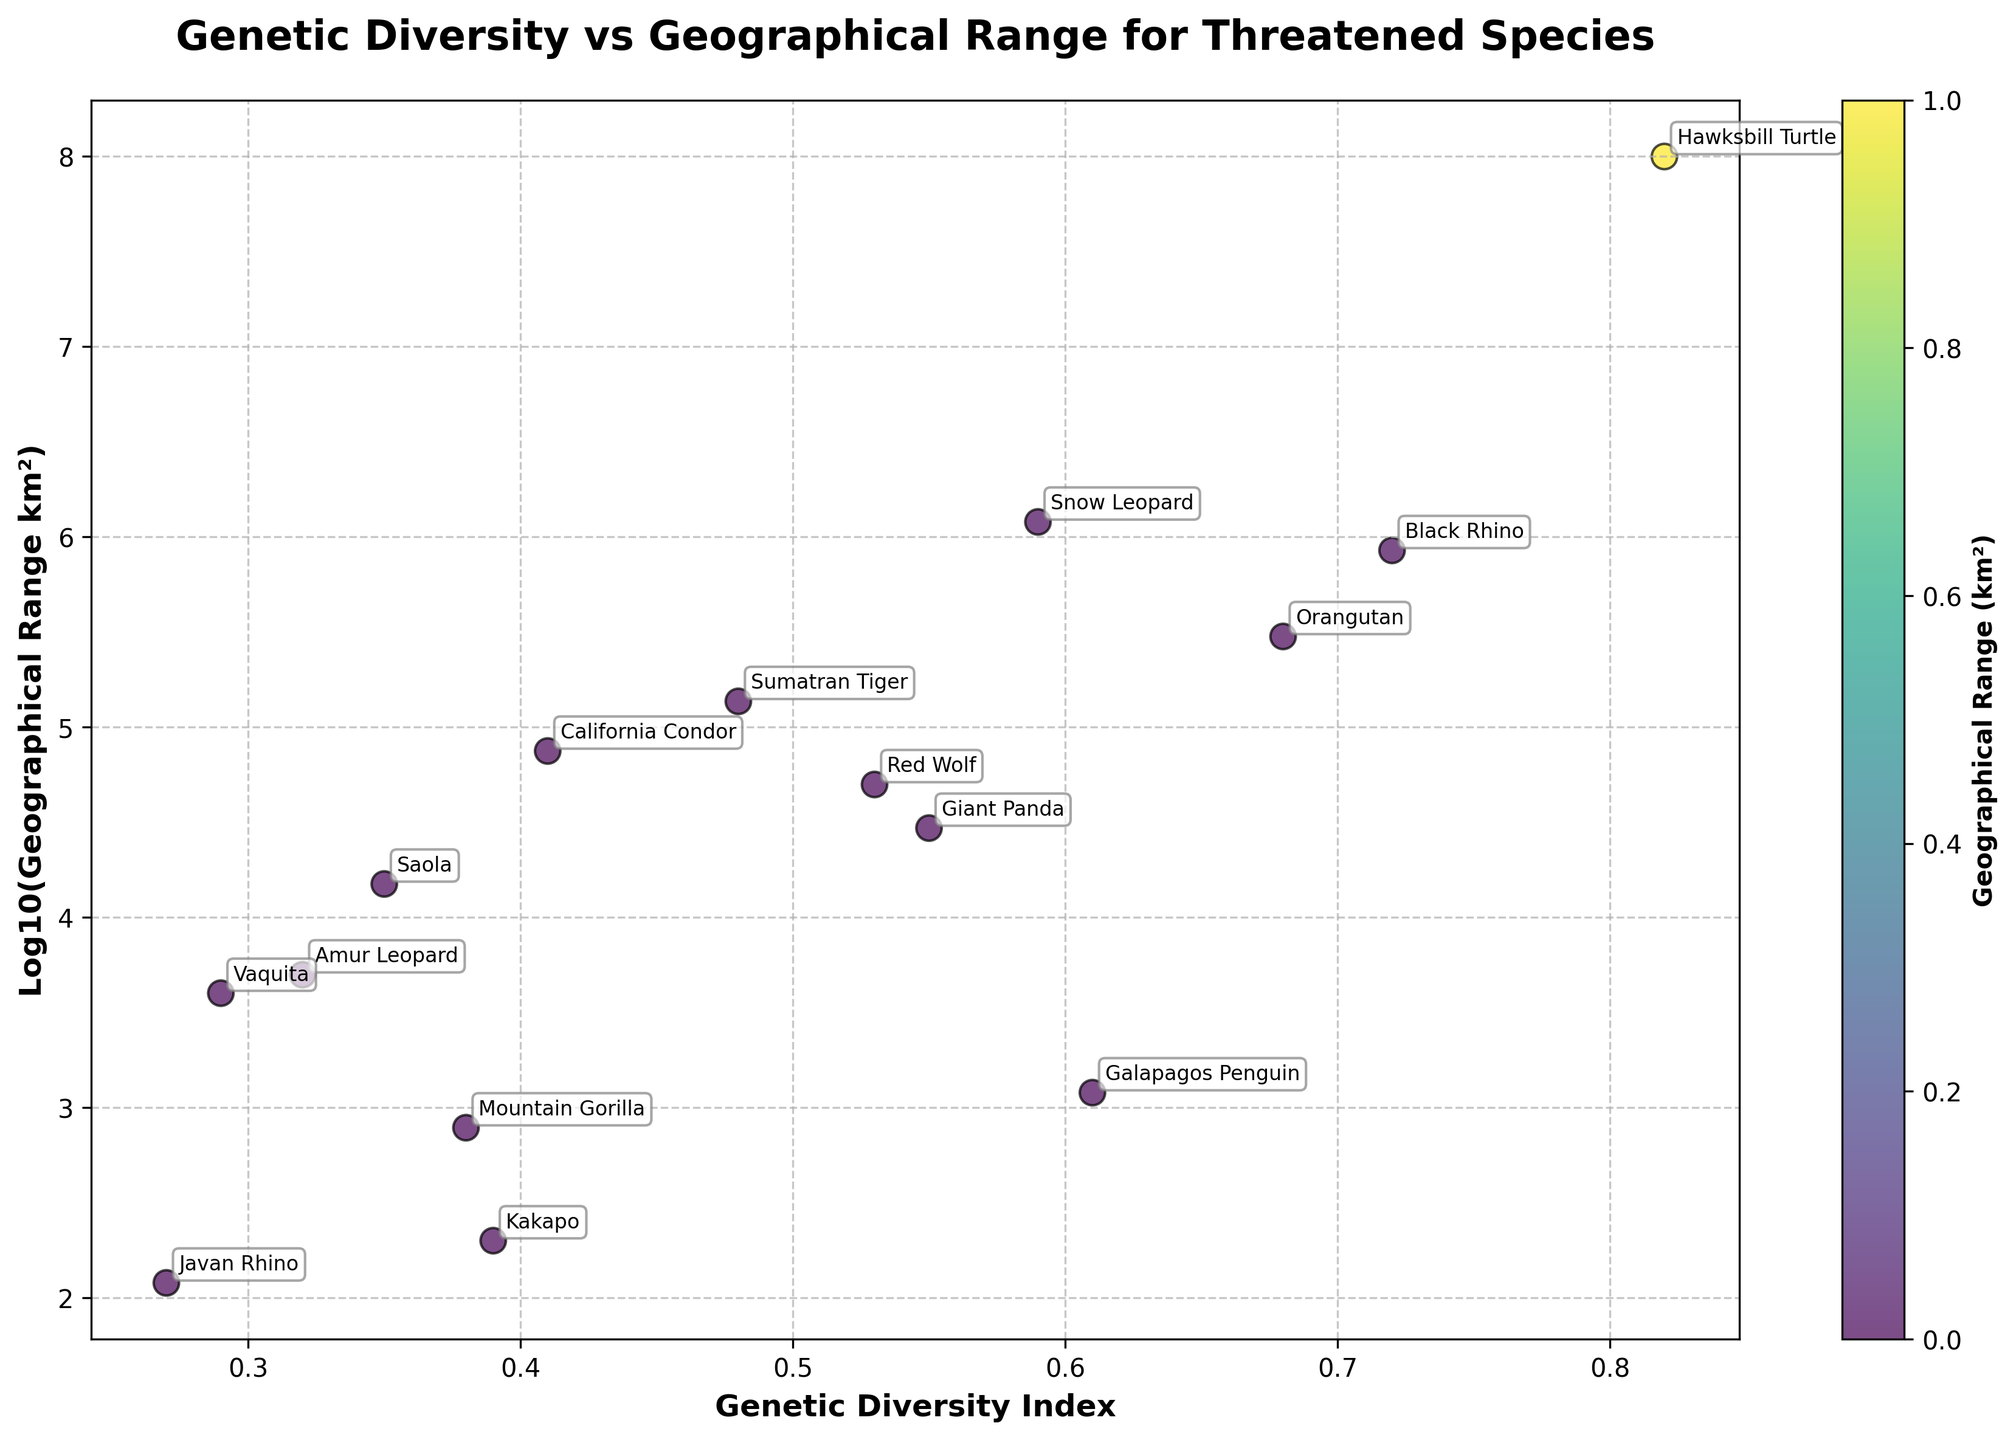What is the title of the figure? The title of the figure is usually the large, bold text at the top of the plot. In this case, it's displayed at the center, which is "Genetic Diversity vs Geographical Range for Threatened Species".
Answer: Genetic Diversity vs Geographical Range for Threatened Species How many species are shown in the figure? This can be determined by counting the number of points (or annotations) on the scatter plot. Each point represents a species. By counting the species names annotated near the points, there are 15 species shown.
Answer: 15 Which species has the lowest Genetic Diversity Index? By looking at the scatter plot and identifying the point closest to the left edge of the x-axis, we find Javan Rhino with the lowest Genetic Diversity Index.
Answer: Javan Rhino What is the Genetic Diversity Index and log10(Geographical Range) for the Hawksbill Turtle? Locate the point labeled "Hawksbill Turtle" and read its coordinates on the plot. The Genetic Diversity Index is approximately 0.82 and log10(Geographical Range) is about 8, indicating a geographical range of 100,000,000 km².
Answer: 0.82 and 8 Which species has a logarithmic geographical range of about 2.5? Find the point with a y-value around 2.5. The species closest to this point is the Saola.
Answer: Saola Compare the genetic diversity of the Mountain Gorilla and Galapagos Penguin. Which one has higher diversity? Locate the points for Mountain Gorilla and Galapagos Penguin and compare their x-coordinates. The Galapagos Penguin (0.61) has a higher Genetic Diversity Index than the Mountain Gorilla (0.38).
Answer: Galapagos Penguin Which species appear to have a geographical range of less than 1000 km²? Examine the points on the scatter plot with log10(Geographical Range) of less than 3 (since log10(1000) = 3). The Javan Rhino (log10 value 2.08, actually ~120 km²) and Kakapo (log10 value ~2.3, actually ~200 km²) fall into this category.
Answer: Javan Rhino and Kakapo What is the mean Genetic Diversity Index of species with a geographical range greater than 100,000 km²? Identify points with a log10(Geographical Range) > 5. These species are Black Rhino, Hawksbill Turtle, Orangutan, Snow Leopard, and California Condor. Calculate the mean of their Genetic Diversity Index: (0.72 + 0.82 + 0.68 + 0.59 + 0.41)/5 = 0.644.
Answer: 0.644 Is there a correlation between genetic diversity and geographical range for the species shown? By observing the scatter plot, it appears there is no strong correlation as points are scattered without a distinct trend (positive or negative) in either direction.
Answer: No Which species has the highest geographical range? The color of each point helps infer geographical range. The point with the deepest color corresponds to the Hawksbill Turtle, which has the highest geographical range of 100,000,000 km².
Answer: Hawksbill Turtle 